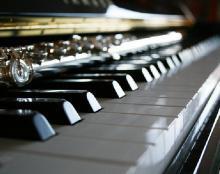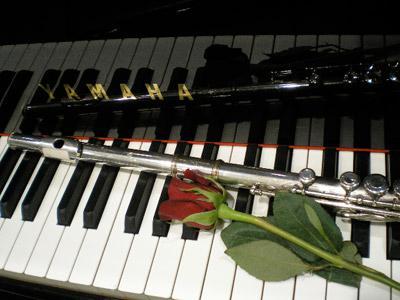The first image is the image on the left, the second image is the image on the right. For the images shown, is this caption "There is exactly one flute resting on piano keys." true? Answer yes or no. No. The first image is the image on the left, the second image is the image on the right. Analyze the images presented: Is the assertion "An image shows one silver wind instrument laid at an angle across the keys of a brown wood-grain piano that faces rightward." valid? Answer yes or no. No. 